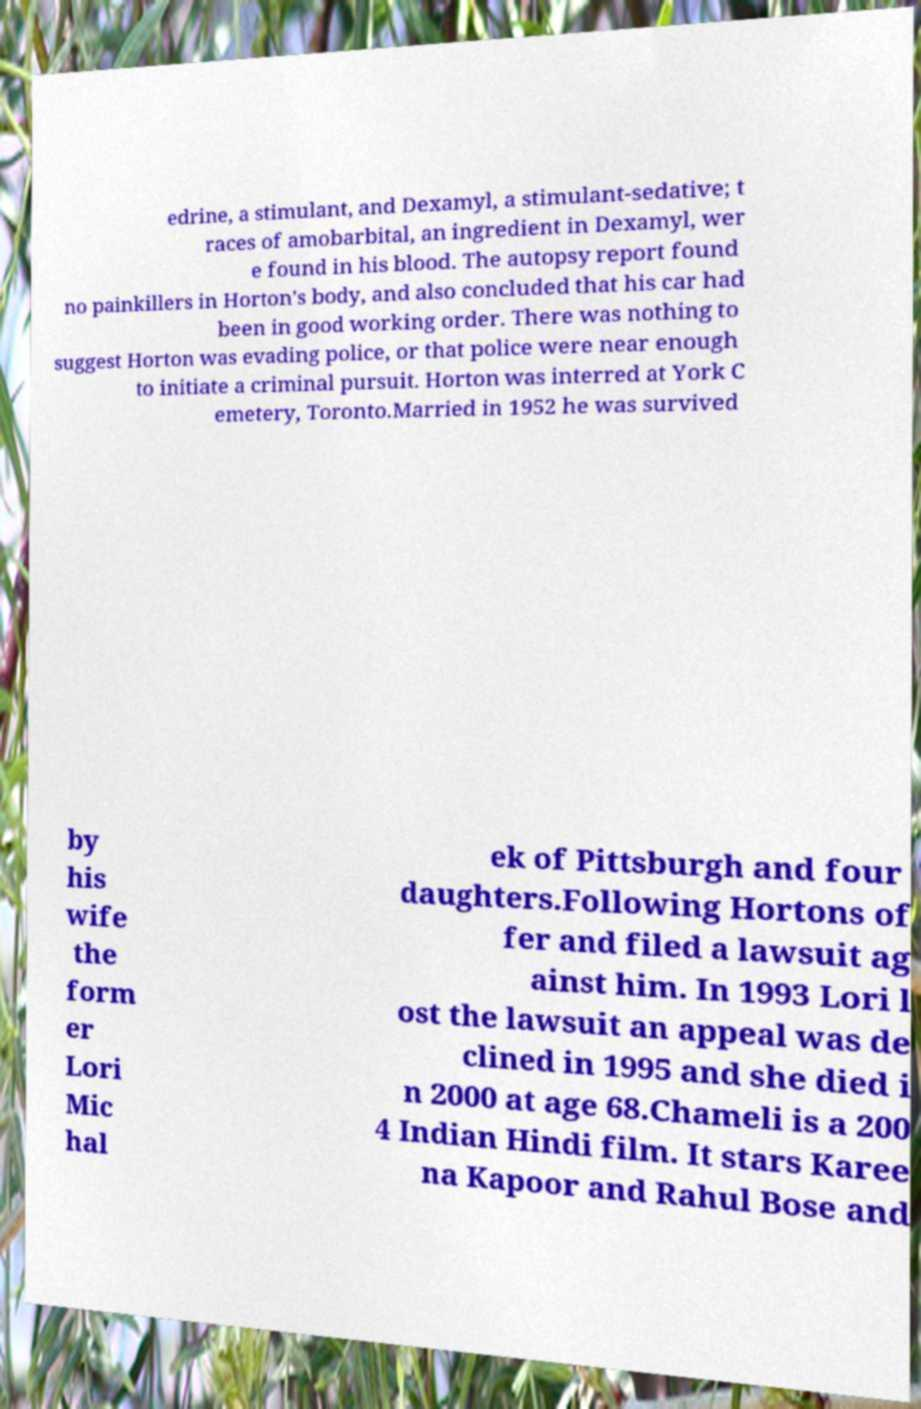Please identify and transcribe the text found in this image. edrine, a stimulant, and Dexamyl, a stimulant-sedative; t races of amobarbital, an ingredient in Dexamyl, wer e found in his blood. The autopsy report found no painkillers in Horton's body, and also concluded that his car had been in good working order. There was nothing to suggest Horton was evading police, or that police were near enough to initiate a criminal pursuit. Horton was interred at York C emetery, Toronto.Married in 1952 he was survived by his wife the form er Lori Mic hal ek of Pittsburgh and four daughters.Following Hortons of fer and filed a lawsuit ag ainst him. In 1993 Lori l ost the lawsuit an appeal was de clined in 1995 and she died i n 2000 at age 68.Chameli is a 200 4 Indian Hindi film. It stars Karee na Kapoor and Rahul Bose and 